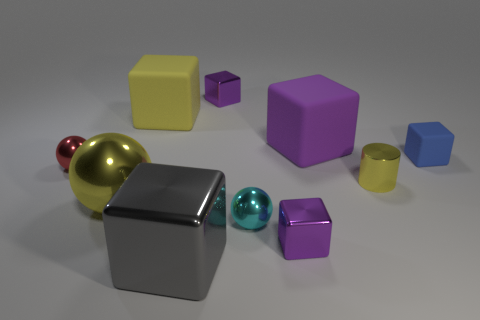Is the number of blue things to the left of the purple matte block greater than the number of metallic objects on the right side of the blue rubber cube?
Give a very brief answer. No. What number of balls are either big red objects or purple rubber things?
Your answer should be compact. 0. Are there any other things that are the same size as the blue block?
Keep it short and to the point. Yes. There is a small purple thing that is to the left of the cyan shiny sphere; does it have the same shape as the red thing?
Ensure brevity in your answer.  No. What color is the large sphere?
Keep it short and to the point. Yellow. What is the color of the other tiny object that is the same shape as the small red thing?
Give a very brief answer. Cyan. What number of gray metal things have the same shape as the cyan metal thing?
Make the answer very short. 0. How many things are either big gray matte cylinders or yellow metal things that are right of the large metal block?
Your response must be concise. 1. Is the color of the cylinder the same as the matte block that is to the left of the big purple block?
Give a very brief answer. Yes. What is the size of the thing that is left of the large shiny cube and behind the red sphere?
Keep it short and to the point. Large. 